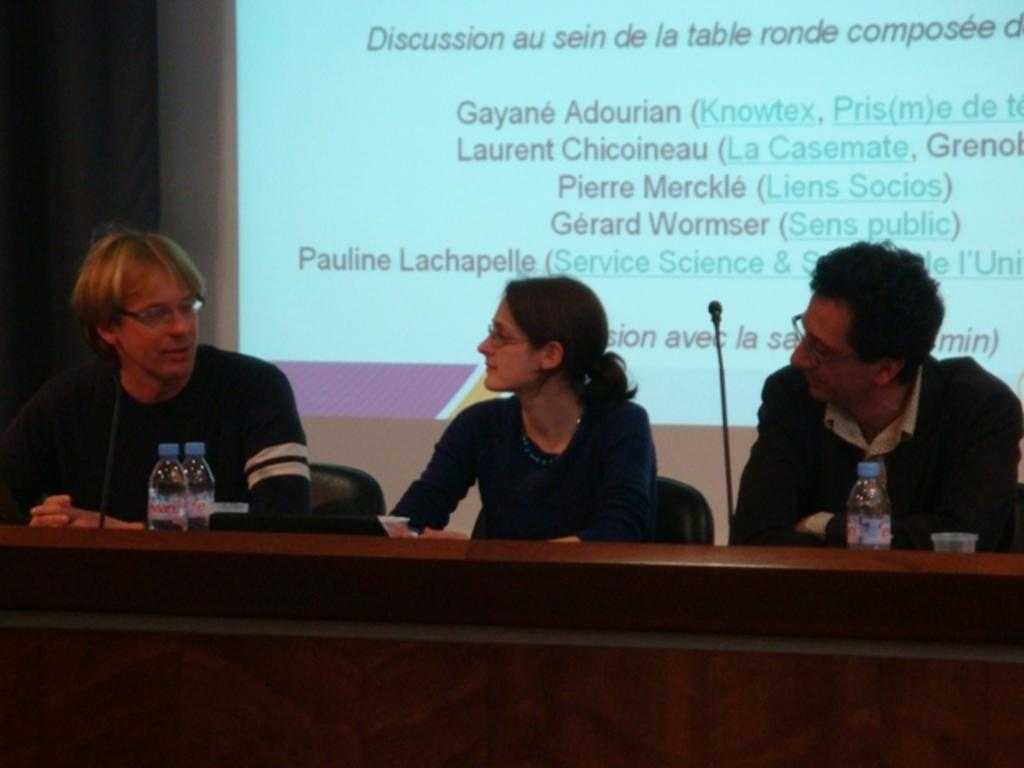What are the people in the image doing? The people in the image are sitting on chairs in the foreground. What is in front of the people? The people are in front of a table. What can be seen on the table? There are mice, bottles, and glasses on the table. What is visible in the background of the image? There is a screen visible in the background. What type of corn is being used to brush the train in the image? There is no corn or train present in the image. 